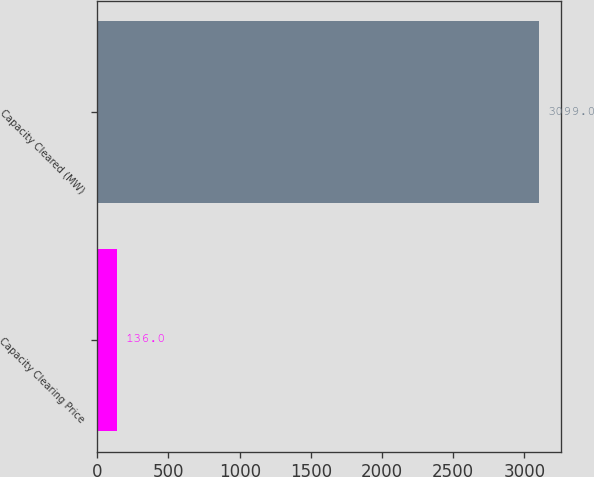<chart> <loc_0><loc_0><loc_500><loc_500><bar_chart><fcel>Capacity Clearing Price<fcel>Capacity Cleared (MW)<nl><fcel>136<fcel>3099<nl></chart> 